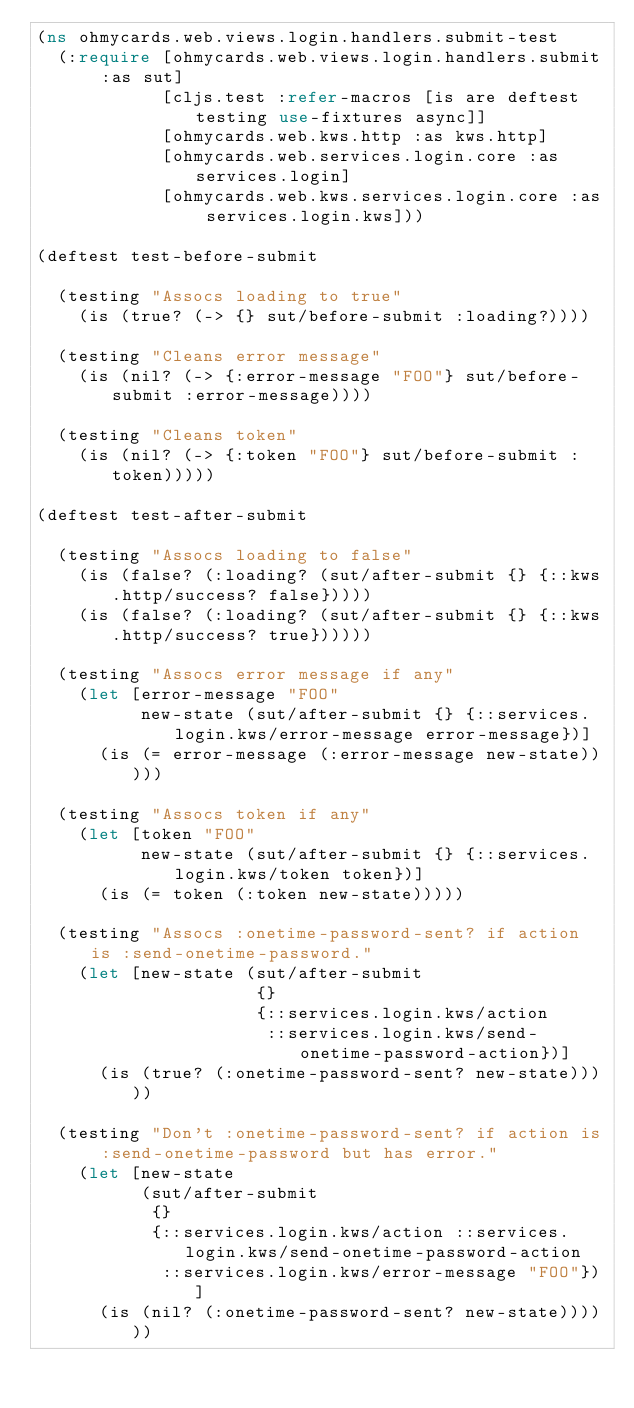Convert code to text. <code><loc_0><loc_0><loc_500><loc_500><_Clojure_>(ns ohmycards.web.views.login.handlers.submit-test
  (:require [ohmycards.web.views.login.handlers.submit :as sut]
            [cljs.test :refer-macros [is are deftest testing use-fixtures async]]
            [ohmycards.web.kws.http :as kws.http]
            [ohmycards.web.services.login.core :as services.login]
            [ohmycards.web.kws.services.login.core :as services.login.kws]))

(deftest test-before-submit

  (testing "Assocs loading to true"
    (is (true? (-> {} sut/before-submit :loading?))))

  (testing "Cleans error message"
    (is (nil? (-> {:error-message "FOO"} sut/before-submit :error-message))))

  (testing "Cleans token"
    (is (nil? (-> {:token "FOO"} sut/before-submit :token)))))

(deftest test-after-submit

  (testing "Assocs loading to false"
    (is (false? (:loading? (sut/after-submit {} {::kws.http/success? false}))))
    (is (false? (:loading? (sut/after-submit {} {::kws.http/success? true})))))

  (testing "Assocs error message if any"
    (let [error-message "FOO"
          new-state (sut/after-submit {} {::services.login.kws/error-message error-message})]
      (is (= error-message (:error-message new-state)))))

  (testing "Assocs token if any"
    (let [token "FOO"
          new-state (sut/after-submit {} {::services.login.kws/token token})]
      (is (= token (:token new-state)))))

  (testing "Assocs :onetime-password-sent? if action is :send-onetime-password."
    (let [new-state (sut/after-submit
                     {}
                     {::services.login.kws/action
                      ::services.login.kws/send-onetime-password-action})]
      (is (true? (:onetime-password-sent? new-state)))))

  (testing "Don't :onetime-password-sent? if action is :send-onetime-password but has error."
    (let [new-state
          (sut/after-submit
           {}
           {::services.login.kws/action ::services.login.kws/send-onetime-password-action
            ::services.login.kws/error-message "FOO"})]
      (is (nil? (:onetime-password-sent? new-state))))))
</code> 